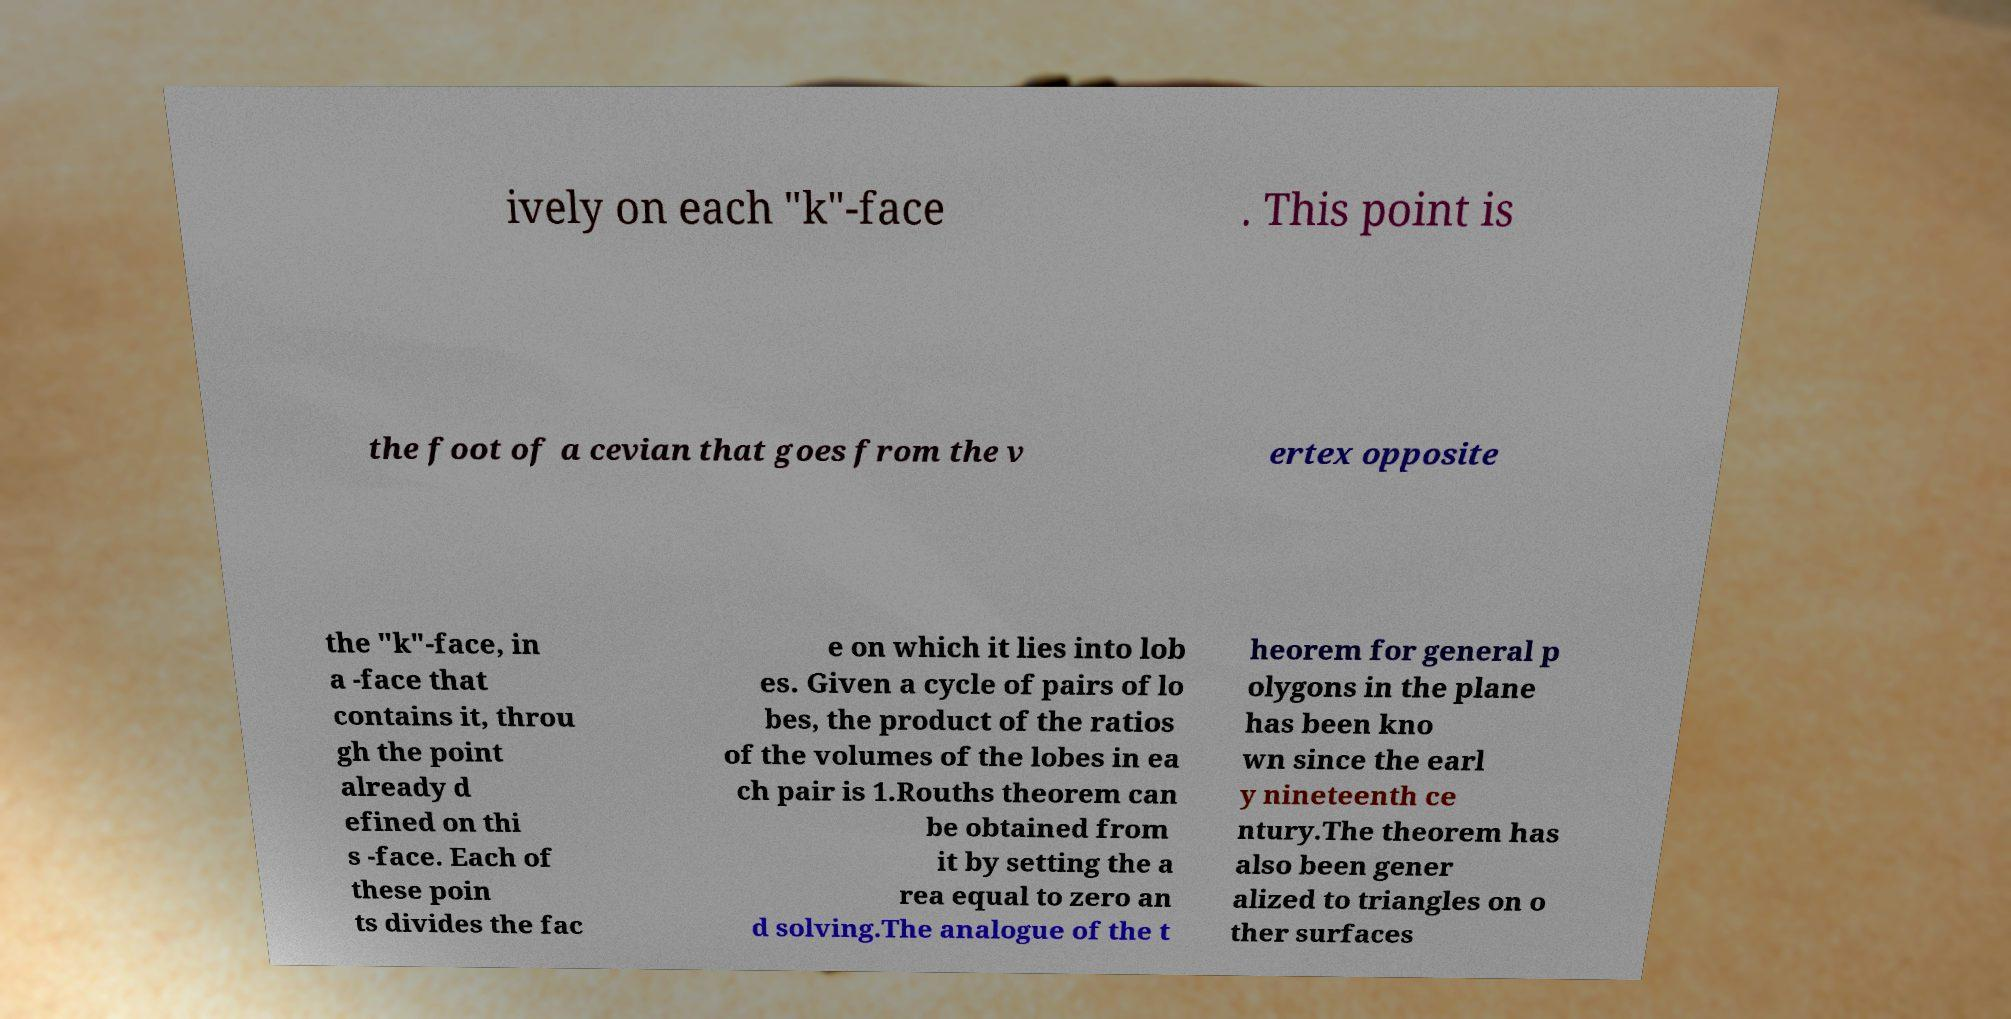Please identify and transcribe the text found in this image. ively on each "k"-face . This point is the foot of a cevian that goes from the v ertex opposite the "k"-face, in a -face that contains it, throu gh the point already d efined on thi s -face. Each of these poin ts divides the fac e on which it lies into lob es. Given a cycle of pairs of lo bes, the product of the ratios of the volumes of the lobes in ea ch pair is 1.Rouths theorem can be obtained from it by setting the a rea equal to zero an d solving.The analogue of the t heorem for general p olygons in the plane has been kno wn since the earl y nineteenth ce ntury.The theorem has also been gener alized to triangles on o ther surfaces 